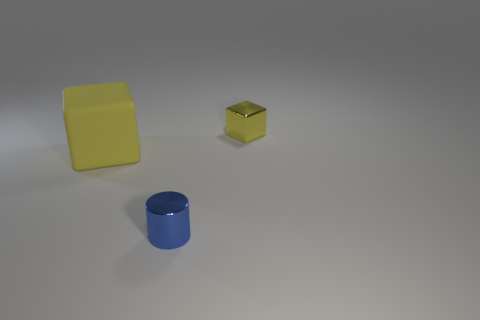Subtract all cyan cubes. Subtract all green cylinders. How many cubes are left? 2 Add 2 big blue cylinders. How many objects exist? 5 Subtract all cylinders. How many objects are left? 2 Add 1 blue metallic things. How many blue metallic things are left? 2 Add 2 small yellow shiny cubes. How many small yellow shiny cubes exist? 3 Subtract 0 yellow spheres. How many objects are left? 3 Subtract all cyan metallic balls. Subtract all metallic objects. How many objects are left? 1 